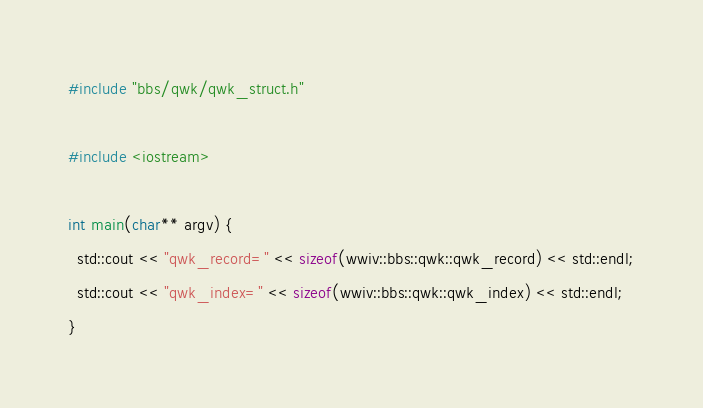<code> <loc_0><loc_0><loc_500><loc_500><_C++_>#include "bbs/qwk/qwk_struct.h"

#include <iostream>

int main(char** argv) {
  std::cout << "qwk_record=" << sizeof(wwiv::bbs::qwk::qwk_record) << std::endl;
  std::cout << "qwk_index=" << sizeof(wwiv::bbs::qwk::qwk_index) << std::endl;
}

</code> 